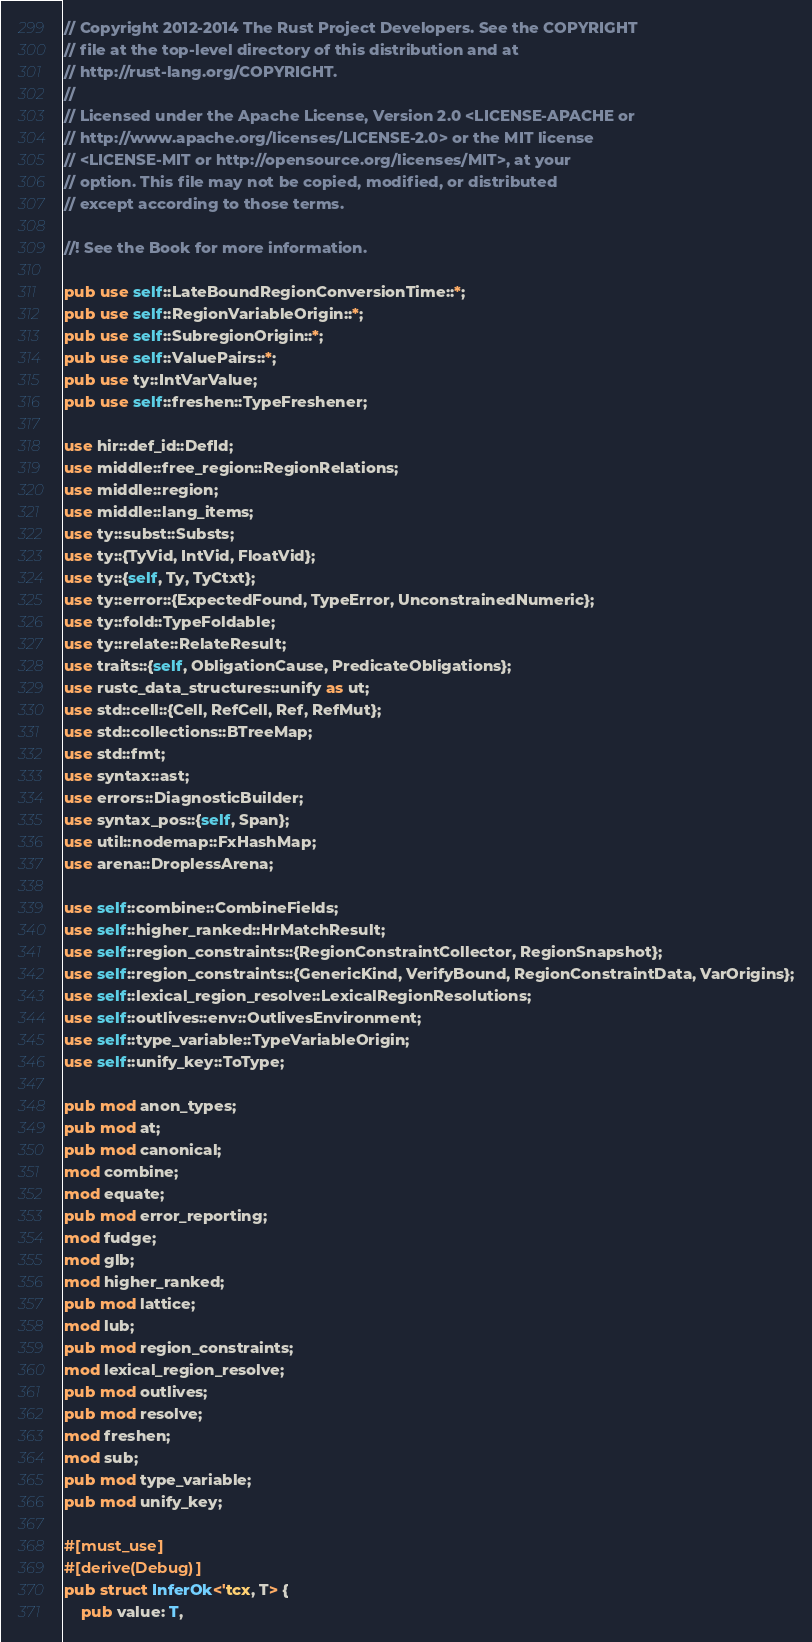<code> <loc_0><loc_0><loc_500><loc_500><_Rust_>// Copyright 2012-2014 The Rust Project Developers. See the COPYRIGHT
// file at the top-level directory of this distribution and at
// http://rust-lang.org/COPYRIGHT.
//
// Licensed under the Apache License, Version 2.0 <LICENSE-APACHE or
// http://www.apache.org/licenses/LICENSE-2.0> or the MIT license
// <LICENSE-MIT or http://opensource.org/licenses/MIT>, at your
// option. This file may not be copied, modified, or distributed
// except according to those terms.

//! See the Book for more information.

pub use self::LateBoundRegionConversionTime::*;
pub use self::RegionVariableOrigin::*;
pub use self::SubregionOrigin::*;
pub use self::ValuePairs::*;
pub use ty::IntVarValue;
pub use self::freshen::TypeFreshener;

use hir::def_id::DefId;
use middle::free_region::RegionRelations;
use middle::region;
use middle::lang_items;
use ty::subst::Substs;
use ty::{TyVid, IntVid, FloatVid};
use ty::{self, Ty, TyCtxt};
use ty::error::{ExpectedFound, TypeError, UnconstrainedNumeric};
use ty::fold::TypeFoldable;
use ty::relate::RelateResult;
use traits::{self, ObligationCause, PredicateObligations};
use rustc_data_structures::unify as ut;
use std::cell::{Cell, RefCell, Ref, RefMut};
use std::collections::BTreeMap;
use std::fmt;
use syntax::ast;
use errors::DiagnosticBuilder;
use syntax_pos::{self, Span};
use util::nodemap::FxHashMap;
use arena::DroplessArena;

use self::combine::CombineFields;
use self::higher_ranked::HrMatchResult;
use self::region_constraints::{RegionConstraintCollector, RegionSnapshot};
use self::region_constraints::{GenericKind, VerifyBound, RegionConstraintData, VarOrigins};
use self::lexical_region_resolve::LexicalRegionResolutions;
use self::outlives::env::OutlivesEnvironment;
use self::type_variable::TypeVariableOrigin;
use self::unify_key::ToType;

pub mod anon_types;
pub mod at;
pub mod canonical;
mod combine;
mod equate;
pub mod error_reporting;
mod fudge;
mod glb;
mod higher_ranked;
pub mod lattice;
mod lub;
pub mod region_constraints;
mod lexical_region_resolve;
pub mod outlives;
pub mod resolve;
mod freshen;
mod sub;
pub mod type_variable;
pub mod unify_key;

#[must_use]
#[derive(Debug)]
pub struct InferOk<'tcx, T> {
    pub value: T,</code> 